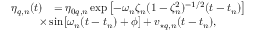<formula> <loc_0><loc_0><loc_500><loc_500>\begin{array} { r l } { \eta _ { q , n } ( t ) } & { = \eta _ { 0 q , n } \exp \, \left [ { - \omega _ { n } \zeta _ { n } ( 1 - \zeta _ { n } ^ { 2 } ) ^ { - 1 / 2 } ( t - t _ { n } ) } \right ] } \\ & { \, \times \sin \, \left [ \omega _ { n } ( t - t _ { n } ) + \phi \right ] + v _ { ^ { * } q , n } ( t - t _ { n } ) , } \end{array}</formula> 